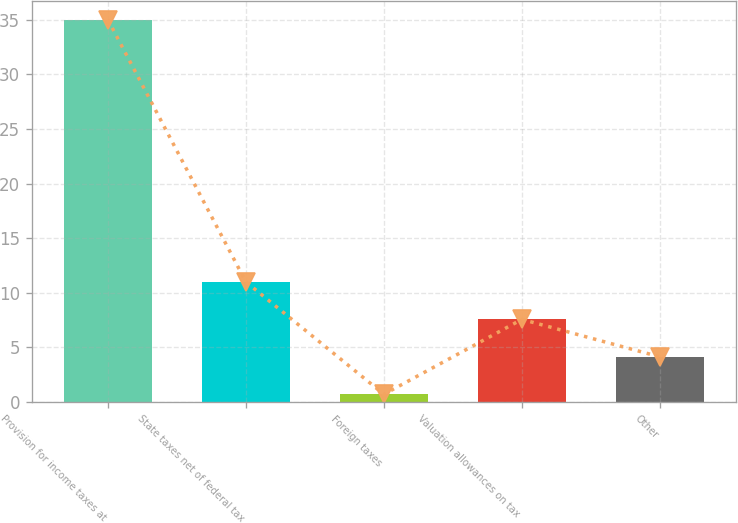Convert chart to OTSL. <chart><loc_0><loc_0><loc_500><loc_500><bar_chart><fcel>Provision for income taxes at<fcel>State taxes net of federal tax<fcel>Foreign taxes<fcel>Valuation allowances on tax<fcel>Other<nl><fcel>35<fcel>10.99<fcel>0.7<fcel>7.56<fcel>4.13<nl></chart> 